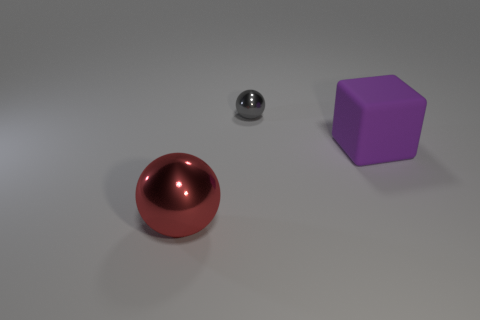Subtract 1 balls. How many balls are left? 1 Subtract all cubes. How many objects are left? 2 Add 1 big purple rubber blocks. How many objects exist? 4 Subtract all red spheres. How many spheres are left? 1 Subtract 0 green cubes. How many objects are left? 3 Subtract all cyan balls. Subtract all purple cubes. How many balls are left? 2 Subtract all purple cubes. How many green spheres are left? 0 Subtract all small gray matte cubes. Subtract all shiny balls. How many objects are left? 1 Add 2 gray metal spheres. How many gray metal spheres are left? 3 Add 2 large cyan matte objects. How many large cyan matte objects exist? 2 